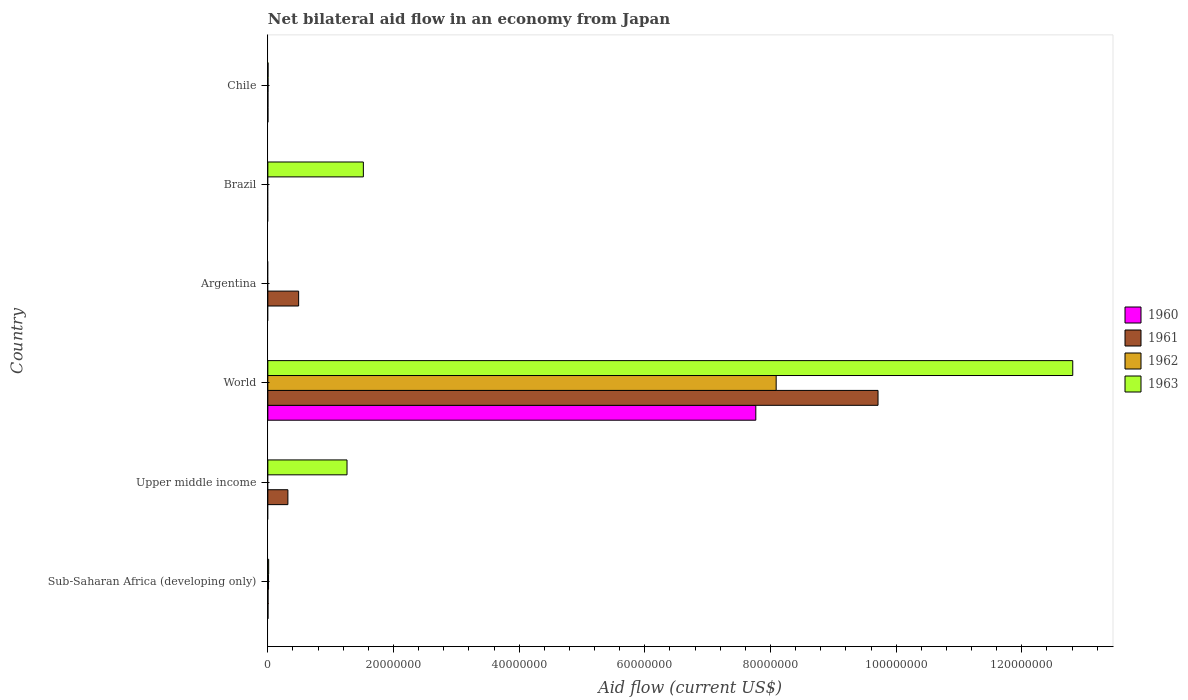Are the number of bars per tick equal to the number of legend labels?
Offer a very short reply. No. How many bars are there on the 6th tick from the top?
Keep it short and to the point. 4. What is the label of the 5th group of bars from the top?
Your response must be concise. Upper middle income. In how many cases, is the number of bars for a given country not equal to the number of legend labels?
Offer a terse response. 3. What is the net bilateral aid flow in 1961 in Sub-Saharan Africa (developing only)?
Keep it short and to the point. 3.00e+04. Across all countries, what is the maximum net bilateral aid flow in 1963?
Your answer should be compact. 1.28e+08. In which country was the net bilateral aid flow in 1960 maximum?
Make the answer very short. World. What is the total net bilateral aid flow in 1960 in the graph?
Provide a short and direct response. 7.77e+07. What is the difference between the net bilateral aid flow in 1963 in Chile and that in World?
Offer a terse response. -1.28e+08. What is the difference between the net bilateral aid flow in 1961 in World and the net bilateral aid flow in 1960 in Upper middle income?
Provide a succinct answer. 9.71e+07. What is the average net bilateral aid flow in 1960 per country?
Offer a terse response. 1.29e+07. Is the difference between the net bilateral aid flow in 1962 in Chile and Sub-Saharan Africa (developing only) greater than the difference between the net bilateral aid flow in 1963 in Chile and Sub-Saharan Africa (developing only)?
Give a very brief answer. Yes. What is the difference between the highest and the second highest net bilateral aid flow in 1962?
Your response must be concise. 8.08e+07. What is the difference between the highest and the lowest net bilateral aid flow in 1960?
Offer a very short reply. 7.77e+07. In how many countries, is the net bilateral aid flow in 1961 greater than the average net bilateral aid flow in 1961 taken over all countries?
Ensure brevity in your answer.  1. Is the sum of the net bilateral aid flow in 1962 in Sub-Saharan Africa (developing only) and World greater than the maximum net bilateral aid flow in 1963 across all countries?
Your response must be concise. No. Is it the case that in every country, the sum of the net bilateral aid flow in 1962 and net bilateral aid flow in 1961 is greater than the net bilateral aid flow in 1963?
Your answer should be very brief. No. How many countries are there in the graph?
Your response must be concise. 6. What is the difference between two consecutive major ticks on the X-axis?
Offer a very short reply. 2.00e+07. Are the values on the major ticks of X-axis written in scientific E-notation?
Offer a terse response. No. Does the graph contain any zero values?
Make the answer very short. Yes. Where does the legend appear in the graph?
Make the answer very short. Center right. How are the legend labels stacked?
Offer a terse response. Vertical. What is the title of the graph?
Offer a terse response. Net bilateral aid flow in an economy from Japan. What is the Aid flow (current US$) of 1960 in Sub-Saharan Africa (developing only)?
Your answer should be compact. 2.00e+04. What is the Aid flow (current US$) of 1961 in Sub-Saharan Africa (developing only)?
Offer a terse response. 3.00e+04. What is the Aid flow (current US$) of 1962 in Sub-Saharan Africa (developing only)?
Keep it short and to the point. 1.10e+05. What is the Aid flow (current US$) of 1960 in Upper middle income?
Provide a short and direct response. 0. What is the Aid flow (current US$) in 1961 in Upper middle income?
Make the answer very short. 3.19e+06. What is the Aid flow (current US$) of 1963 in Upper middle income?
Keep it short and to the point. 1.26e+07. What is the Aid flow (current US$) of 1960 in World?
Your answer should be compact. 7.77e+07. What is the Aid flow (current US$) in 1961 in World?
Provide a succinct answer. 9.71e+07. What is the Aid flow (current US$) of 1962 in World?
Offer a very short reply. 8.09e+07. What is the Aid flow (current US$) in 1963 in World?
Your response must be concise. 1.28e+08. What is the Aid flow (current US$) in 1960 in Argentina?
Your answer should be compact. 0. What is the Aid flow (current US$) of 1961 in Argentina?
Provide a succinct answer. 4.90e+06. What is the Aid flow (current US$) of 1963 in Argentina?
Offer a terse response. 0. What is the Aid flow (current US$) in 1961 in Brazil?
Your answer should be very brief. 0. What is the Aid flow (current US$) in 1962 in Brazil?
Provide a short and direct response. 0. What is the Aid flow (current US$) in 1963 in Brazil?
Give a very brief answer. 1.52e+07. What is the Aid flow (current US$) of 1962 in Chile?
Offer a terse response. 2.00e+04. Across all countries, what is the maximum Aid flow (current US$) in 1960?
Make the answer very short. 7.77e+07. Across all countries, what is the maximum Aid flow (current US$) in 1961?
Provide a succinct answer. 9.71e+07. Across all countries, what is the maximum Aid flow (current US$) in 1962?
Give a very brief answer. 8.09e+07. Across all countries, what is the maximum Aid flow (current US$) of 1963?
Offer a terse response. 1.28e+08. Across all countries, what is the minimum Aid flow (current US$) of 1961?
Give a very brief answer. 0. Across all countries, what is the minimum Aid flow (current US$) of 1962?
Provide a succinct answer. 0. What is the total Aid flow (current US$) of 1960 in the graph?
Make the answer very short. 7.77e+07. What is the total Aid flow (current US$) of 1961 in the graph?
Keep it short and to the point. 1.05e+08. What is the total Aid flow (current US$) in 1962 in the graph?
Your response must be concise. 8.10e+07. What is the total Aid flow (current US$) in 1963 in the graph?
Ensure brevity in your answer.  1.56e+08. What is the difference between the Aid flow (current US$) of 1961 in Sub-Saharan Africa (developing only) and that in Upper middle income?
Make the answer very short. -3.16e+06. What is the difference between the Aid flow (current US$) in 1963 in Sub-Saharan Africa (developing only) and that in Upper middle income?
Offer a terse response. -1.25e+07. What is the difference between the Aid flow (current US$) of 1960 in Sub-Saharan Africa (developing only) and that in World?
Offer a very short reply. -7.76e+07. What is the difference between the Aid flow (current US$) in 1961 in Sub-Saharan Africa (developing only) and that in World?
Provide a succinct answer. -9.71e+07. What is the difference between the Aid flow (current US$) of 1962 in Sub-Saharan Africa (developing only) and that in World?
Provide a succinct answer. -8.08e+07. What is the difference between the Aid flow (current US$) in 1963 in Sub-Saharan Africa (developing only) and that in World?
Give a very brief answer. -1.28e+08. What is the difference between the Aid flow (current US$) of 1961 in Sub-Saharan Africa (developing only) and that in Argentina?
Your response must be concise. -4.87e+06. What is the difference between the Aid flow (current US$) of 1963 in Sub-Saharan Africa (developing only) and that in Brazil?
Keep it short and to the point. -1.51e+07. What is the difference between the Aid flow (current US$) in 1960 in Sub-Saharan Africa (developing only) and that in Chile?
Your response must be concise. 10000. What is the difference between the Aid flow (current US$) of 1961 in Upper middle income and that in World?
Your answer should be very brief. -9.39e+07. What is the difference between the Aid flow (current US$) in 1963 in Upper middle income and that in World?
Make the answer very short. -1.16e+08. What is the difference between the Aid flow (current US$) in 1961 in Upper middle income and that in Argentina?
Your response must be concise. -1.71e+06. What is the difference between the Aid flow (current US$) in 1963 in Upper middle income and that in Brazil?
Your response must be concise. -2.60e+06. What is the difference between the Aid flow (current US$) of 1961 in Upper middle income and that in Chile?
Your answer should be very brief. 3.18e+06. What is the difference between the Aid flow (current US$) in 1963 in Upper middle income and that in Chile?
Give a very brief answer. 1.26e+07. What is the difference between the Aid flow (current US$) of 1961 in World and that in Argentina?
Offer a terse response. 9.22e+07. What is the difference between the Aid flow (current US$) of 1963 in World and that in Brazil?
Your answer should be very brief. 1.13e+08. What is the difference between the Aid flow (current US$) in 1960 in World and that in Chile?
Your answer should be very brief. 7.76e+07. What is the difference between the Aid flow (current US$) in 1961 in World and that in Chile?
Your answer should be compact. 9.71e+07. What is the difference between the Aid flow (current US$) of 1962 in World and that in Chile?
Give a very brief answer. 8.09e+07. What is the difference between the Aid flow (current US$) of 1963 in World and that in Chile?
Your answer should be very brief. 1.28e+08. What is the difference between the Aid flow (current US$) in 1961 in Argentina and that in Chile?
Give a very brief answer. 4.89e+06. What is the difference between the Aid flow (current US$) in 1963 in Brazil and that in Chile?
Your answer should be compact. 1.52e+07. What is the difference between the Aid flow (current US$) of 1960 in Sub-Saharan Africa (developing only) and the Aid flow (current US$) of 1961 in Upper middle income?
Make the answer very short. -3.17e+06. What is the difference between the Aid flow (current US$) of 1960 in Sub-Saharan Africa (developing only) and the Aid flow (current US$) of 1963 in Upper middle income?
Provide a succinct answer. -1.26e+07. What is the difference between the Aid flow (current US$) of 1961 in Sub-Saharan Africa (developing only) and the Aid flow (current US$) of 1963 in Upper middle income?
Keep it short and to the point. -1.26e+07. What is the difference between the Aid flow (current US$) of 1962 in Sub-Saharan Africa (developing only) and the Aid flow (current US$) of 1963 in Upper middle income?
Ensure brevity in your answer.  -1.25e+07. What is the difference between the Aid flow (current US$) of 1960 in Sub-Saharan Africa (developing only) and the Aid flow (current US$) of 1961 in World?
Provide a succinct answer. -9.71e+07. What is the difference between the Aid flow (current US$) in 1960 in Sub-Saharan Africa (developing only) and the Aid flow (current US$) in 1962 in World?
Your answer should be compact. -8.09e+07. What is the difference between the Aid flow (current US$) of 1960 in Sub-Saharan Africa (developing only) and the Aid flow (current US$) of 1963 in World?
Your response must be concise. -1.28e+08. What is the difference between the Aid flow (current US$) of 1961 in Sub-Saharan Africa (developing only) and the Aid flow (current US$) of 1962 in World?
Offer a terse response. -8.09e+07. What is the difference between the Aid flow (current US$) in 1961 in Sub-Saharan Africa (developing only) and the Aid flow (current US$) in 1963 in World?
Provide a succinct answer. -1.28e+08. What is the difference between the Aid flow (current US$) in 1962 in Sub-Saharan Africa (developing only) and the Aid flow (current US$) in 1963 in World?
Ensure brevity in your answer.  -1.28e+08. What is the difference between the Aid flow (current US$) of 1960 in Sub-Saharan Africa (developing only) and the Aid flow (current US$) of 1961 in Argentina?
Provide a short and direct response. -4.88e+06. What is the difference between the Aid flow (current US$) in 1960 in Sub-Saharan Africa (developing only) and the Aid flow (current US$) in 1963 in Brazil?
Your answer should be very brief. -1.52e+07. What is the difference between the Aid flow (current US$) of 1961 in Sub-Saharan Africa (developing only) and the Aid flow (current US$) of 1963 in Brazil?
Your answer should be very brief. -1.52e+07. What is the difference between the Aid flow (current US$) of 1962 in Sub-Saharan Africa (developing only) and the Aid flow (current US$) of 1963 in Brazil?
Provide a succinct answer. -1.51e+07. What is the difference between the Aid flow (current US$) of 1960 in Sub-Saharan Africa (developing only) and the Aid flow (current US$) of 1962 in Chile?
Your answer should be very brief. 0. What is the difference between the Aid flow (current US$) in 1960 in Sub-Saharan Africa (developing only) and the Aid flow (current US$) in 1963 in Chile?
Your response must be concise. -10000. What is the difference between the Aid flow (current US$) of 1961 in Sub-Saharan Africa (developing only) and the Aid flow (current US$) of 1962 in Chile?
Give a very brief answer. 10000. What is the difference between the Aid flow (current US$) of 1961 in Upper middle income and the Aid flow (current US$) of 1962 in World?
Offer a very short reply. -7.77e+07. What is the difference between the Aid flow (current US$) in 1961 in Upper middle income and the Aid flow (current US$) in 1963 in World?
Offer a very short reply. -1.25e+08. What is the difference between the Aid flow (current US$) of 1961 in Upper middle income and the Aid flow (current US$) of 1963 in Brazil?
Your response must be concise. -1.20e+07. What is the difference between the Aid flow (current US$) of 1961 in Upper middle income and the Aid flow (current US$) of 1962 in Chile?
Provide a short and direct response. 3.17e+06. What is the difference between the Aid flow (current US$) of 1961 in Upper middle income and the Aid flow (current US$) of 1963 in Chile?
Give a very brief answer. 3.16e+06. What is the difference between the Aid flow (current US$) in 1960 in World and the Aid flow (current US$) in 1961 in Argentina?
Keep it short and to the point. 7.28e+07. What is the difference between the Aid flow (current US$) in 1960 in World and the Aid flow (current US$) in 1963 in Brazil?
Make the answer very short. 6.25e+07. What is the difference between the Aid flow (current US$) of 1961 in World and the Aid flow (current US$) of 1963 in Brazil?
Provide a short and direct response. 8.19e+07. What is the difference between the Aid flow (current US$) in 1962 in World and the Aid flow (current US$) in 1963 in Brazil?
Give a very brief answer. 6.57e+07. What is the difference between the Aid flow (current US$) in 1960 in World and the Aid flow (current US$) in 1961 in Chile?
Provide a succinct answer. 7.76e+07. What is the difference between the Aid flow (current US$) in 1960 in World and the Aid flow (current US$) in 1962 in Chile?
Give a very brief answer. 7.76e+07. What is the difference between the Aid flow (current US$) in 1960 in World and the Aid flow (current US$) in 1963 in Chile?
Your answer should be compact. 7.76e+07. What is the difference between the Aid flow (current US$) in 1961 in World and the Aid flow (current US$) in 1962 in Chile?
Give a very brief answer. 9.71e+07. What is the difference between the Aid flow (current US$) in 1961 in World and the Aid flow (current US$) in 1963 in Chile?
Your answer should be very brief. 9.71e+07. What is the difference between the Aid flow (current US$) in 1962 in World and the Aid flow (current US$) in 1963 in Chile?
Give a very brief answer. 8.09e+07. What is the difference between the Aid flow (current US$) in 1961 in Argentina and the Aid flow (current US$) in 1963 in Brazil?
Your answer should be very brief. -1.03e+07. What is the difference between the Aid flow (current US$) of 1961 in Argentina and the Aid flow (current US$) of 1962 in Chile?
Your answer should be compact. 4.88e+06. What is the difference between the Aid flow (current US$) in 1961 in Argentina and the Aid flow (current US$) in 1963 in Chile?
Offer a very short reply. 4.87e+06. What is the average Aid flow (current US$) of 1960 per country?
Keep it short and to the point. 1.29e+07. What is the average Aid flow (current US$) in 1961 per country?
Keep it short and to the point. 1.75e+07. What is the average Aid flow (current US$) of 1962 per country?
Give a very brief answer. 1.35e+07. What is the average Aid flow (current US$) in 1963 per country?
Your response must be concise. 2.60e+07. What is the difference between the Aid flow (current US$) of 1962 and Aid flow (current US$) of 1963 in Sub-Saharan Africa (developing only)?
Your response must be concise. -2.00e+04. What is the difference between the Aid flow (current US$) of 1961 and Aid flow (current US$) of 1963 in Upper middle income?
Provide a short and direct response. -9.41e+06. What is the difference between the Aid flow (current US$) of 1960 and Aid flow (current US$) of 1961 in World?
Ensure brevity in your answer.  -1.94e+07. What is the difference between the Aid flow (current US$) in 1960 and Aid flow (current US$) in 1962 in World?
Your answer should be compact. -3.24e+06. What is the difference between the Aid flow (current US$) of 1960 and Aid flow (current US$) of 1963 in World?
Give a very brief answer. -5.04e+07. What is the difference between the Aid flow (current US$) of 1961 and Aid flow (current US$) of 1962 in World?
Your answer should be compact. 1.62e+07. What is the difference between the Aid flow (current US$) of 1961 and Aid flow (current US$) of 1963 in World?
Your answer should be very brief. -3.10e+07. What is the difference between the Aid flow (current US$) of 1962 and Aid flow (current US$) of 1963 in World?
Give a very brief answer. -4.72e+07. What is the difference between the Aid flow (current US$) in 1960 and Aid flow (current US$) in 1962 in Chile?
Offer a very short reply. -10000. What is the difference between the Aid flow (current US$) of 1960 and Aid flow (current US$) of 1963 in Chile?
Ensure brevity in your answer.  -2.00e+04. What is the difference between the Aid flow (current US$) in 1961 and Aid flow (current US$) in 1962 in Chile?
Offer a very short reply. -10000. What is the ratio of the Aid flow (current US$) of 1961 in Sub-Saharan Africa (developing only) to that in Upper middle income?
Your response must be concise. 0.01. What is the ratio of the Aid flow (current US$) in 1963 in Sub-Saharan Africa (developing only) to that in Upper middle income?
Your answer should be compact. 0.01. What is the ratio of the Aid flow (current US$) in 1961 in Sub-Saharan Africa (developing only) to that in World?
Your response must be concise. 0. What is the ratio of the Aid flow (current US$) of 1962 in Sub-Saharan Africa (developing only) to that in World?
Give a very brief answer. 0. What is the ratio of the Aid flow (current US$) in 1961 in Sub-Saharan Africa (developing only) to that in Argentina?
Ensure brevity in your answer.  0.01. What is the ratio of the Aid flow (current US$) in 1963 in Sub-Saharan Africa (developing only) to that in Brazil?
Your answer should be very brief. 0.01. What is the ratio of the Aid flow (current US$) of 1960 in Sub-Saharan Africa (developing only) to that in Chile?
Your answer should be very brief. 2. What is the ratio of the Aid flow (current US$) in 1962 in Sub-Saharan Africa (developing only) to that in Chile?
Give a very brief answer. 5.5. What is the ratio of the Aid flow (current US$) of 1963 in Sub-Saharan Africa (developing only) to that in Chile?
Your answer should be compact. 4.33. What is the ratio of the Aid flow (current US$) in 1961 in Upper middle income to that in World?
Make the answer very short. 0.03. What is the ratio of the Aid flow (current US$) in 1963 in Upper middle income to that in World?
Your answer should be very brief. 0.1. What is the ratio of the Aid flow (current US$) of 1961 in Upper middle income to that in Argentina?
Your answer should be compact. 0.65. What is the ratio of the Aid flow (current US$) in 1963 in Upper middle income to that in Brazil?
Ensure brevity in your answer.  0.83. What is the ratio of the Aid flow (current US$) of 1961 in Upper middle income to that in Chile?
Your answer should be compact. 319. What is the ratio of the Aid flow (current US$) of 1963 in Upper middle income to that in Chile?
Your answer should be very brief. 420. What is the ratio of the Aid flow (current US$) in 1961 in World to that in Argentina?
Offer a terse response. 19.82. What is the ratio of the Aid flow (current US$) in 1963 in World to that in Brazil?
Your answer should be very brief. 8.43. What is the ratio of the Aid flow (current US$) of 1960 in World to that in Chile?
Give a very brief answer. 7766. What is the ratio of the Aid flow (current US$) of 1961 in World to that in Chile?
Give a very brief answer. 9711. What is the ratio of the Aid flow (current US$) of 1962 in World to that in Chile?
Provide a succinct answer. 4045. What is the ratio of the Aid flow (current US$) in 1963 in World to that in Chile?
Your answer should be compact. 4270. What is the ratio of the Aid flow (current US$) in 1961 in Argentina to that in Chile?
Offer a terse response. 490. What is the ratio of the Aid flow (current US$) in 1963 in Brazil to that in Chile?
Your response must be concise. 506.67. What is the difference between the highest and the second highest Aid flow (current US$) of 1960?
Offer a terse response. 7.76e+07. What is the difference between the highest and the second highest Aid flow (current US$) in 1961?
Your answer should be very brief. 9.22e+07. What is the difference between the highest and the second highest Aid flow (current US$) in 1962?
Your response must be concise. 8.08e+07. What is the difference between the highest and the second highest Aid flow (current US$) of 1963?
Provide a succinct answer. 1.13e+08. What is the difference between the highest and the lowest Aid flow (current US$) of 1960?
Offer a very short reply. 7.77e+07. What is the difference between the highest and the lowest Aid flow (current US$) in 1961?
Provide a succinct answer. 9.71e+07. What is the difference between the highest and the lowest Aid flow (current US$) in 1962?
Ensure brevity in your answer.  8.09e+07. What is the difference between the highest and the lowest Aid flow (current US$) of 1963?
Make the answer very short. 1.28e+08. 